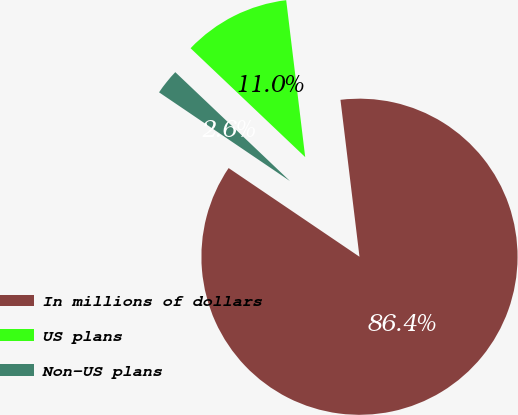Convert chart to OTSL. <chart><loc_0><loc_0><loc_500><loc_500><pie_chart><fcel>In millions of dollars<fcel>US plans<fcel>Non-US plans<nl><fcel>86.39%<fcel>10.99%<fcel>2.61%<nl></chart> 